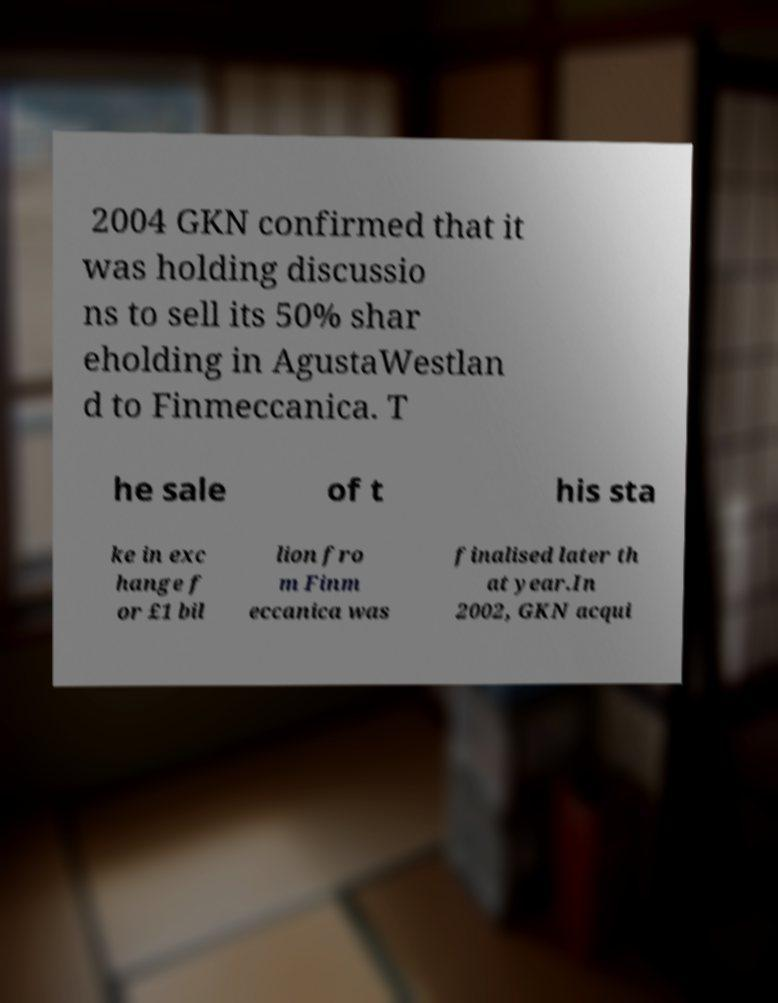Can you accurately transcribe the text from the provided image for me? 2004 GKN confirmed that it was holding discussio ns to sell its 50% shar eholding in AgustaWestlan d to Finmeccanica. T he sale of t his sta ke in exc hange f or £1 bil lion fro m Finm eccanica was finalised later th at year.In 2002, GKN acqui 